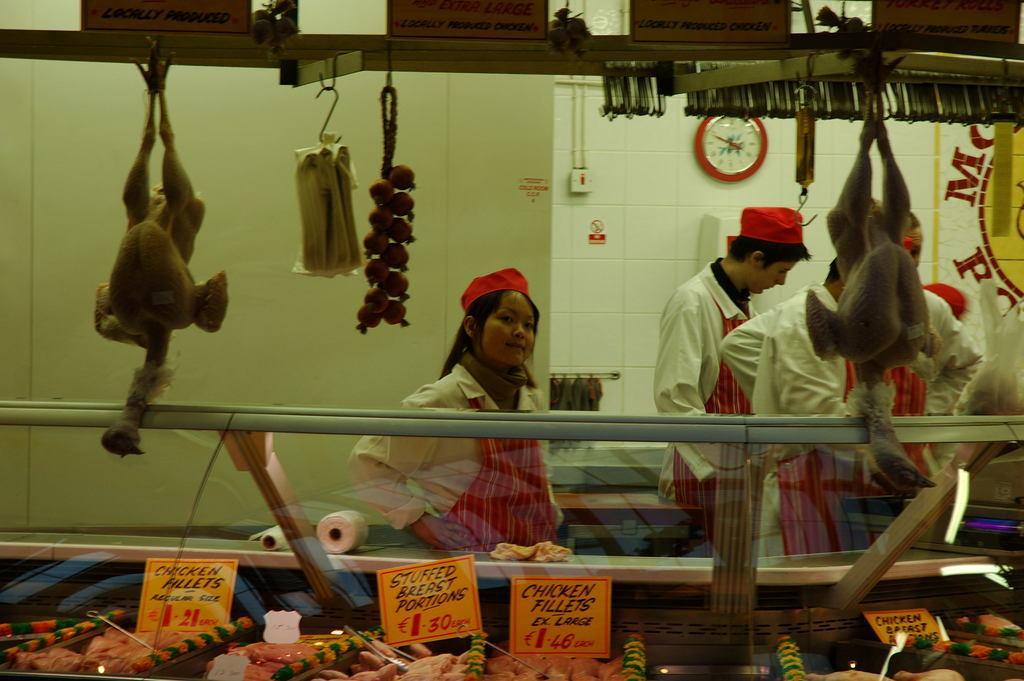In one or two sentences, can you explain what this image depicts? In the picture I can see the glass display cabinet at the bottom of the image and I can see the chicken recipes in the glass display cabinet. I can see a few persons wearing the white color clothes. There is a clock on the wall. I can see the hanger stand at the top of the picture and I can see two chickens hanging in the stand. 